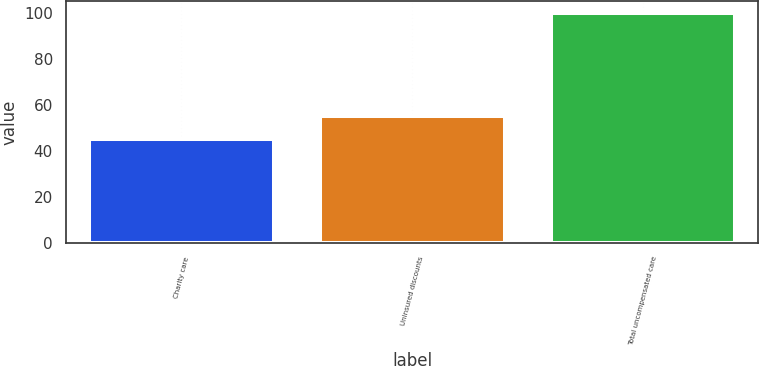Convert chart to OTSL. <chart><loc_0><loc_0><loc_500><loc_500><bar_chart><fcel>Charity care<fcel>Uninsured discounts<fcel>Total uncompensated care<nl><fcel>45<fcel>55<fcel>100<nl></chart> 